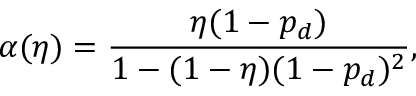<formula> <loc_0><loc_0><loc_500><loc_500>\alpha ( \eta ) = \frac { \eta ( 1 - p _ { d } ) } { 1 - ( 1 - \eta ) ( 1 - p _ { d } ) ^ { 2 } } ,</formula> 